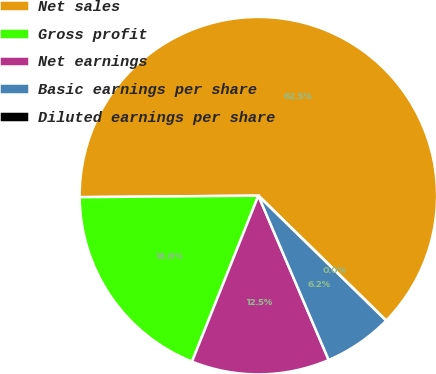<chart> <loc_0><loc_0><loc_500><loc_500><pie_chart><fcel>Net sales<fcel>Gross profit<fcel>Net earnings<fcel>Basic earnings per share<fcel>Diluted earnings per share<nl><fcel>62.45%<fcel>18.81%<fcel>12.49%<fcel>6.25%<fcel>0.0%<nl></chart> 